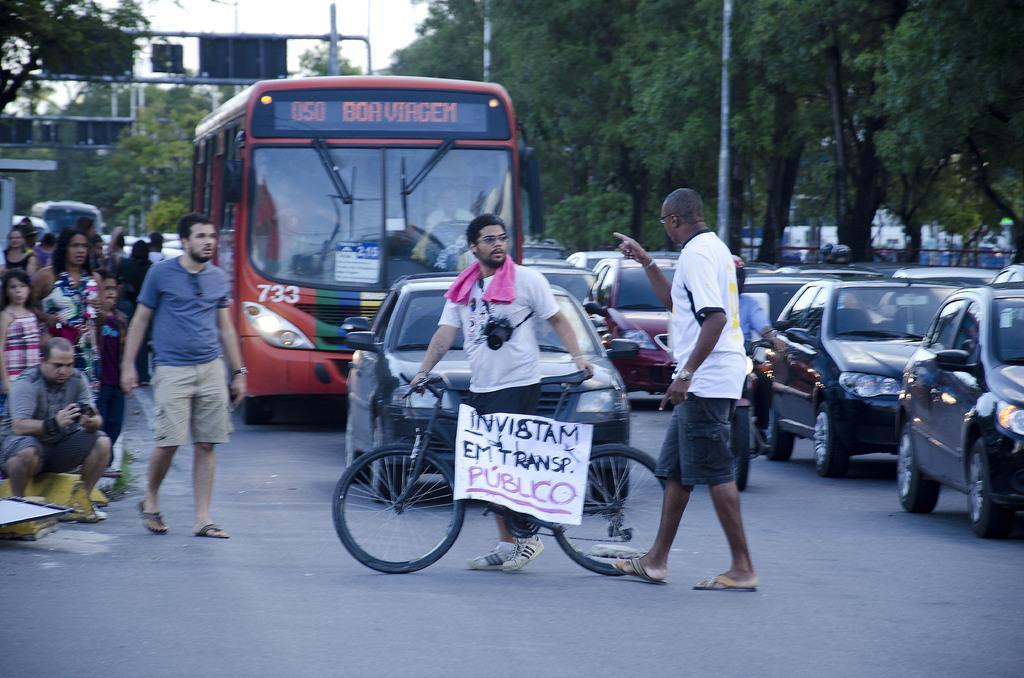Can you describe this image briefly? Vehicles are on the road. This man is holding a bicycle. On this bicycle there is a banner. Left side of the image we can see people. This person is pointing at the opposite person. Background there are trees and poles. 